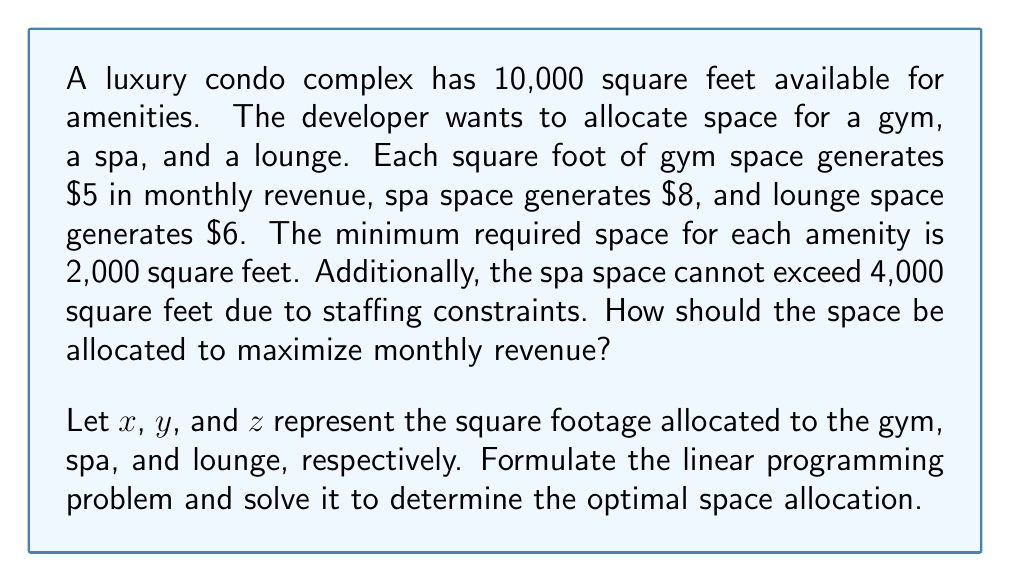Could you help me with this problem? To solve this problem, we'll use linear programming. Let's formulate the problem:

Objective function (maximize monthly revenue):
$$ \text{Maximize } 5x + 8y + 6z $$

Constraints:
1. Total space: $x + y + z = 10000$
2. Minimum space for each amenity: $x \geq 2000$, $y \geq 2000$, $z \geq 2000$
3. Maximum spa space: $y \leq 4000$
4. Non-negativity: $x, y, z \geq 0$

Now, let's solve this using the simplex method:

1. Convert inequality constraints to equations by introducing slack variables:
   $x - s_1 = 2000$
   $y - s_2 = 2000$
   $z - s_3 = 2000$
   $y + s_4 = 4000$

2. Initial tableau:
   $$ \begin{array}{c|cccccccc|c}
      & x & y & z & s_1 & s_2 & s_3 & s_4 & RHS \\
      \hline
      -Z & -5 & -8 & -6 & 0 & 0 & 0 & 0 & 0 \\
      s_1 & 1 & 0 & 0 & 1 & 0 & 0 & 0 & 2000 \\
      s_2 & 0 & 1 & 0 & 0 & 1 & 0 & 0 & 2000 \\
      s_3 & 0 & 0 & 1 & 0 & 0 & 1 & 0 & 2000 \\
      s_4 & 0 & 1 & 0 & 0 & 0 & 0 & 1 & 4000 \\
      R_5 & 1 & 1 & 1 & 0 & 0 & 0 & 0 & 10000 \\
   \end{array} $$

3. Perform pivot operations to optimize:
   - Pivot on y (column 2, row 2)
   - Pivot on x (column 1, row 5)
   - Pivot on z (column 3, row 3)

4. Final tableau:
   $$ \begin{array}{c|cccccccc|c}
      & x & y & z & s_1 & s_2 & s_3 & s_4 & RHS \\
      \hline
      -Z & 0 & 0 & 0 & 1 & 3 & 2 & 0 & 70000 \\
      x & 1 & 0 & 0 & 0 & -1 & -1 & 0 & 4000 \\
      y & 0 & 1 & 0 & 0 & 1 & 0 & 0 & 4000 \\
      z & 0 & 0 & 1 & 0 & 0 & 1 & 0 & 2000 \\
      s_4 & 0 & 0 & 0 & 0 & -1 & 0 & 1 & 0 \\
      s_1 & 0 & 0 & 0 & 1 & 1 & 1 & 0 & 0 \\
   \end{array} $$

The optimal solution is:
$x = 4000$ (gym space)
$y = 4000$ (spa space)
$z = 2000$ (lounge space)

The maximum monthly revenue is $70,000.
Answer: The optimal space allocation is:
Gym: 4,000 sq ft
Spa: 4,000 sq ft
Lounge: 2,000 sq ft
Maximum monthly revenue: $70,000 